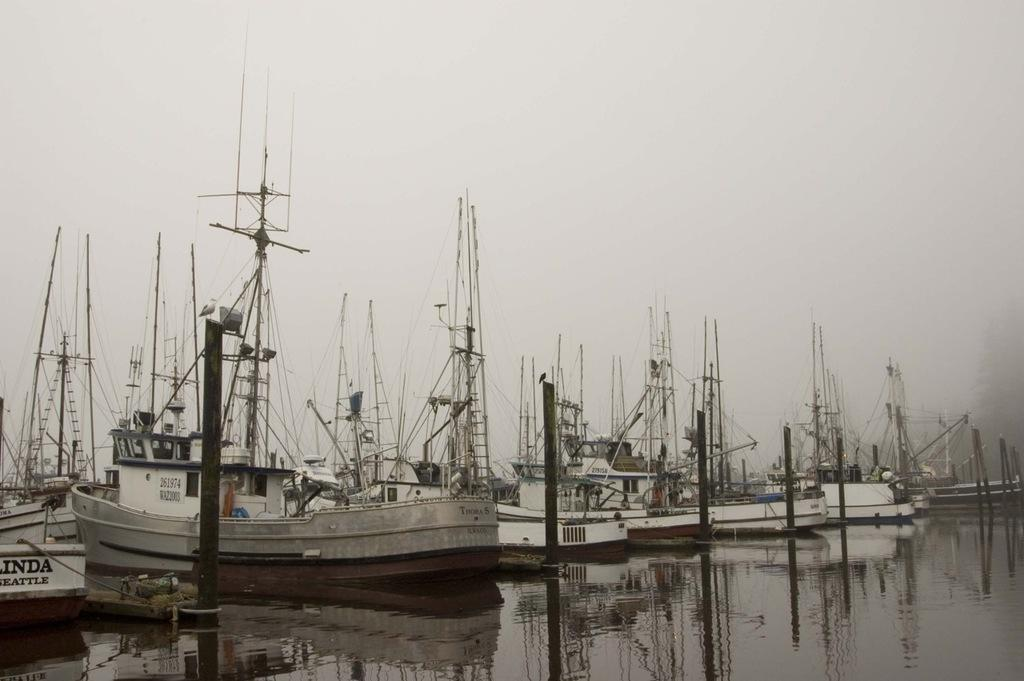<image>
Write a terse but informative summary of the picture. Several ships are lined up next to one from Seattle. 